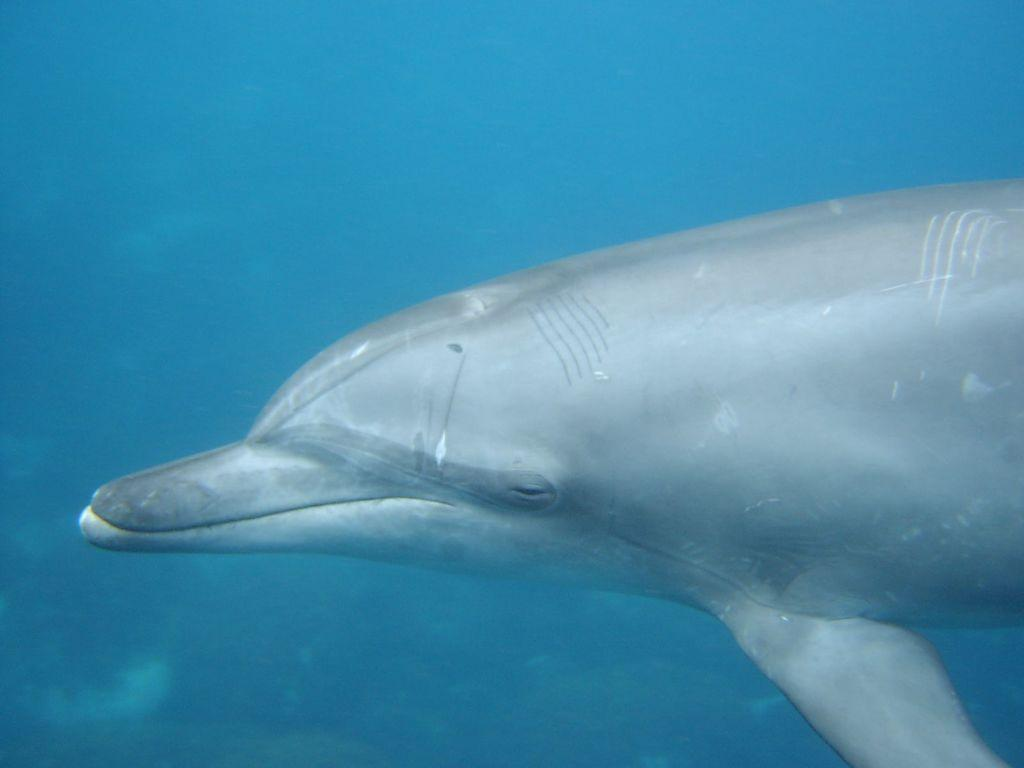What type of animal is in the image? There is an aquatic animal in the image. What color is the aquatic animal? The aquatic animal is grey in color. What is the background of the image? There is blue water visible in the image. How many tents are set up near the aquatic animal in the image? There are no tents present in the image; it features an aquatic animal in blue water. What is the base of the aquatic animal made of in the image? The image does not show the base of the aquatic animal, as it is focused on the animal itself and the blue water. 